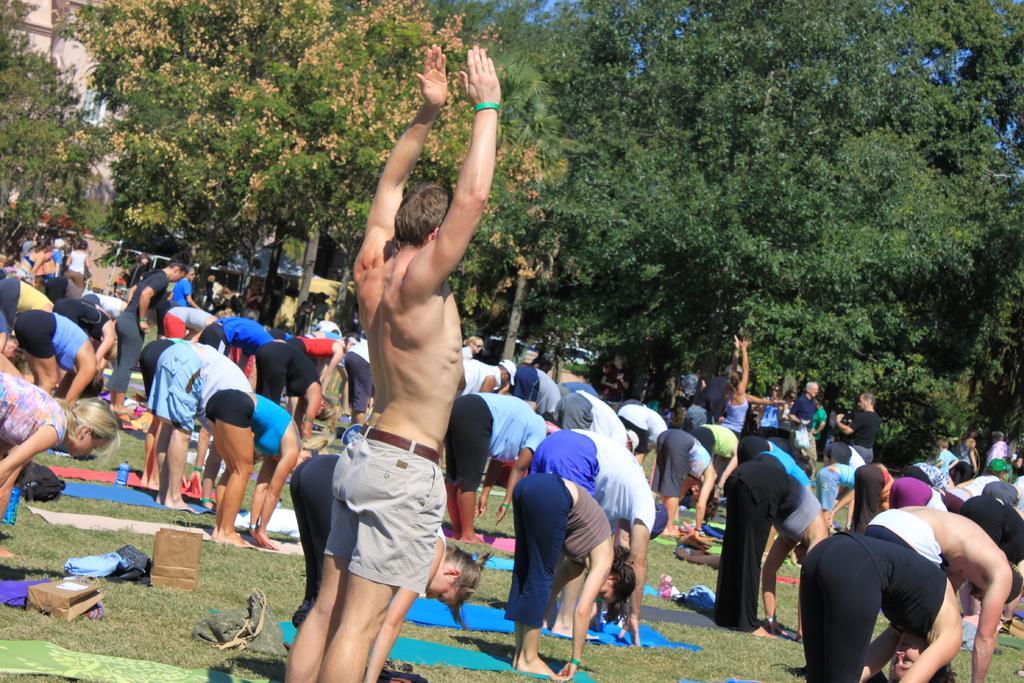How would you summarize this image in a sentence or two? In this image there are so many people doing yoga on the grass, beside them there are so many trees and buildings. 